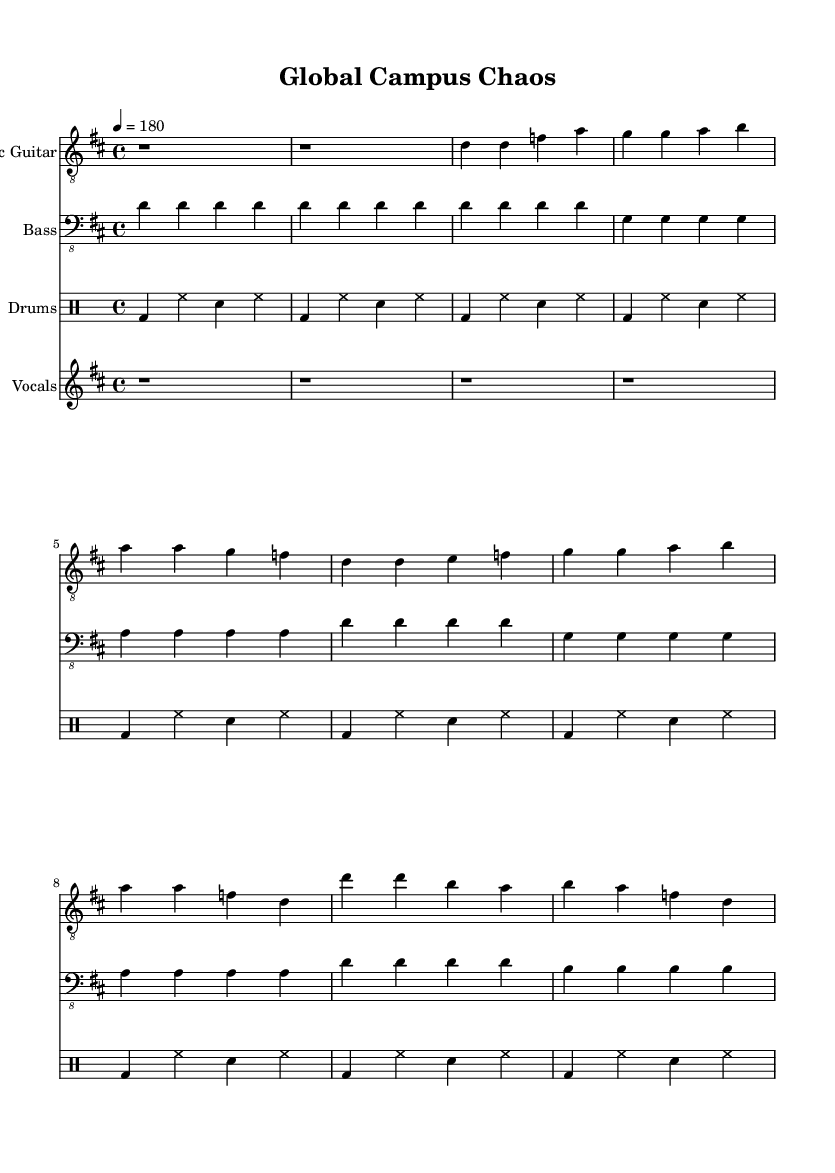What is the key signature of this music? The key signature is D major, which has two sharps (F# and C#). This can be identified from the beginning of the staff where the sharps are indicated.
Answer: D major What is the time signature of this music? The time signature is 4/4, which is noted at the beginning of the score. It indicates that there are four beats in each measure, and the quarter note gets one beat.
Answer: 4/4 What is the tempo marking for this piece? The tempo marking is 180 beats per minute, which indicates how fast the piece should be played. This is stated in the tempo command at the beginning of the score.
Answer: 180 How many measures are in the verse section? The verse section consists of 4 measures. This can be counted from the beginning of the verse (marked by the lyrics) until the chorus begins.
Answer: 4 What is the main theme addressed in the lyrics? The main theme addressed in the lyrics is cultural diversity and unity among international students. This can be inferred from phrases like "Cultural bridges" and "Punk rock unity."
Answer: Cultural diversity Which instruments are featured in this piece? The featured instruments are electric guitar, bass guitar, and drums. This information can be found at the beginning of each staff, which indicates the instrument being played.
Answer: Electric guitar, bass guitar, drums What musical genre does this piece belong to? The piece belongs to the punk genre, which is evident from the style of the music, the energetic tempo, and thematic elements focusing on cultural diversity and youth empowerment.
Answer: Punk 